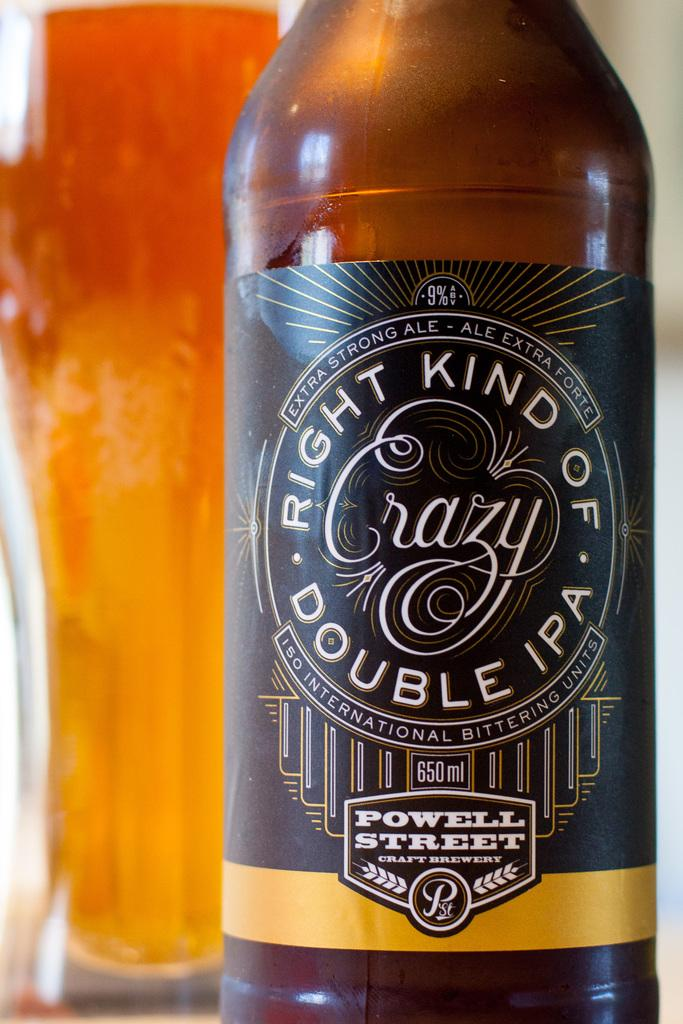Provide a one-sentence caption for the provided image. A bottle of ale from Powell Street brewery sits in front of a full beer glass. 